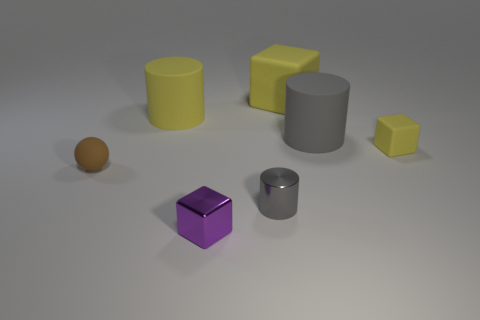How many gray cylinders must be subtracted to get 1 gray cylinders? 1 Subtract all matte blocks. How many blocks are left? 1 Add 1 brown cubes. How many objects exist? 8 Subtract all spheres. How many objects are left? 6 Subtract all gray cylinders. How many cylinders are left? 1 Subtract all blue cylinders. How many yellow blocks are left? 2 Subtract 1 cylinders. How many cylinders are left? 2 Subtract all purple spheres. Subtract all purple cylinders. How many spheres are left? 1 Subtract all large purple rubber cubes. Subtract all tiny yellow matte blocks. How many objects are left? 6 Add 1 gray matte cylinders. How many gray matte cylinders are left? 2 